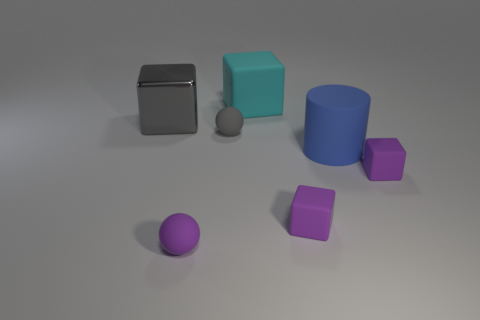Add 1 big matte spheres. How many objects exist? 8 Subtract all matte blocks. How many blocks are left? 1 Subtract all red balls. Subtract all cyan cylinders. How many balls are left? 2 Subtract all cyan blocks. How many green balls are left? 0 Add 6 big cyan cubes. How many big cyan cubes exist? 7 Subtract all cyan blocks. How many blocks are left? 3 Subtract 0 red cylinders. How many objects are left? 7 Subtract all blocks. How many objects are left? 3 Subtract 1 cylinders. How many cylinders are left? 0 Subtract all large yellow matte spheres. Subtract all large cyan cubes. How many objects are left? 6 